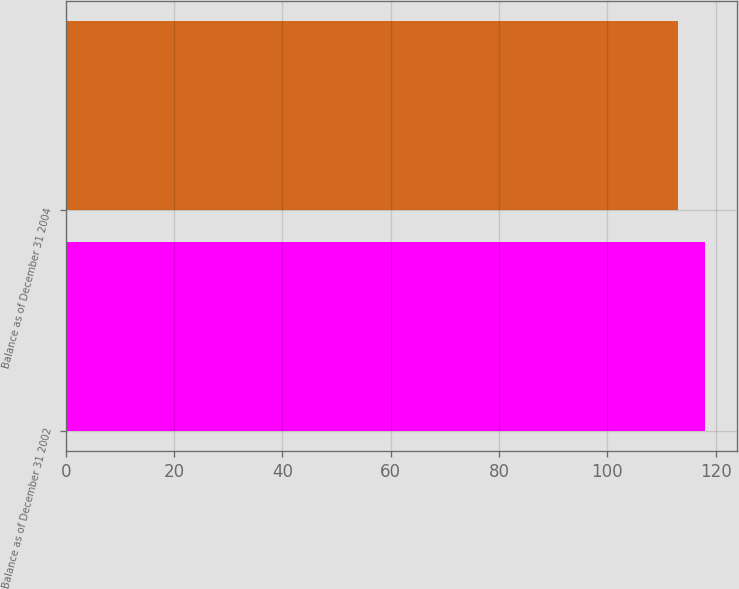<chart> <loc_0><loc_0><loc_500><loc_500><bar_chart><fcel>Balance as of December 31 2002<fcel>Balance as of December 31 2004<nl><fcel>118<fcel>113<nl></chart> 